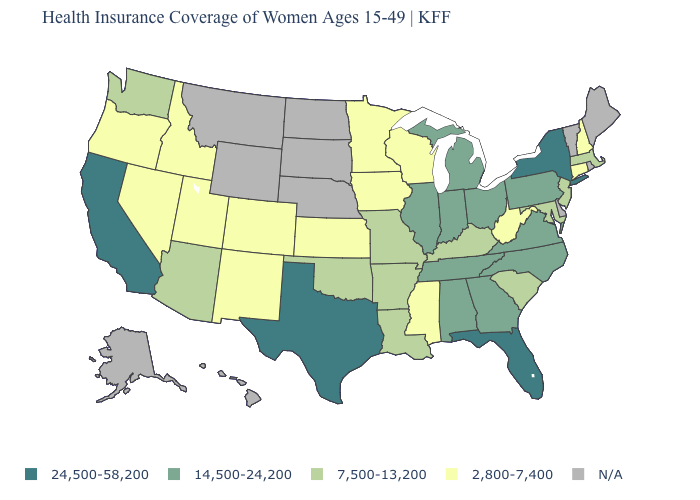Name the states that have a value in the range 24,500-58,200?
Be succinct. California, Florida, New York, Texas. How many symbols are there in the legend?
Keep it brief. 5. Which states have the lowest value in the USA?
Answer briefly. Colorado, Connecticut, Idaho, Iowa, Kansas, Minnesota, Mississippi, Nevada, New Hampshire, New Mexico, Oregon, Utah, West Virginia, Wisconsin. What is the value of New Hampshire?
Concise answer only. 2,800-7,400. Does West Virginia have the lowest value in the South?
Give a very brief answer. Yes. Which states have the lowest value in the Northeast?
Write a very short answer. Connecticut, New Hampshire. Which states have the lowest value in the USA?
Short answer required. Colorado, Connecticut, Idaho, Iowa, Kansas, Minnesota, Mississippi, Nevada, New Hampshire, New Mexico, Oregon, Utah, West Virginia, Wisconsin. Does the map have missing data?
Concise answer only. Yes. Is the legend a continuous bar?
Be succinct. No. Name the states that have a value in the range 14,500-24,200?
Short answer required. Alabama, Georgia, Illinois, Indiana, Michigan, North Carolina, Ohio, Pennsylvania, Tennessee, Virginia. Does Florida have the highest value in the USA?
Quick response, please. Yes. What is the lowest value in the West?
Write a very short answer. 2,800-7,400. Which states have the lowest value in the USA?
Write a very short answer. Colorado, Connecticut, Idaho, Iowa, Kansas, Minnesota, Mississippi, Nevada, New Hampshire, New Mexico, Oregon, Utah, West Virginia, Wisconsin. Name the states that have a value in the range N/A?
Be succinct. Alaska, Delaware, Hawaii, Maine, Montana, Nebraska, North Dakota, Rhode Island, South Dakota, Vermont, Wyoming. 